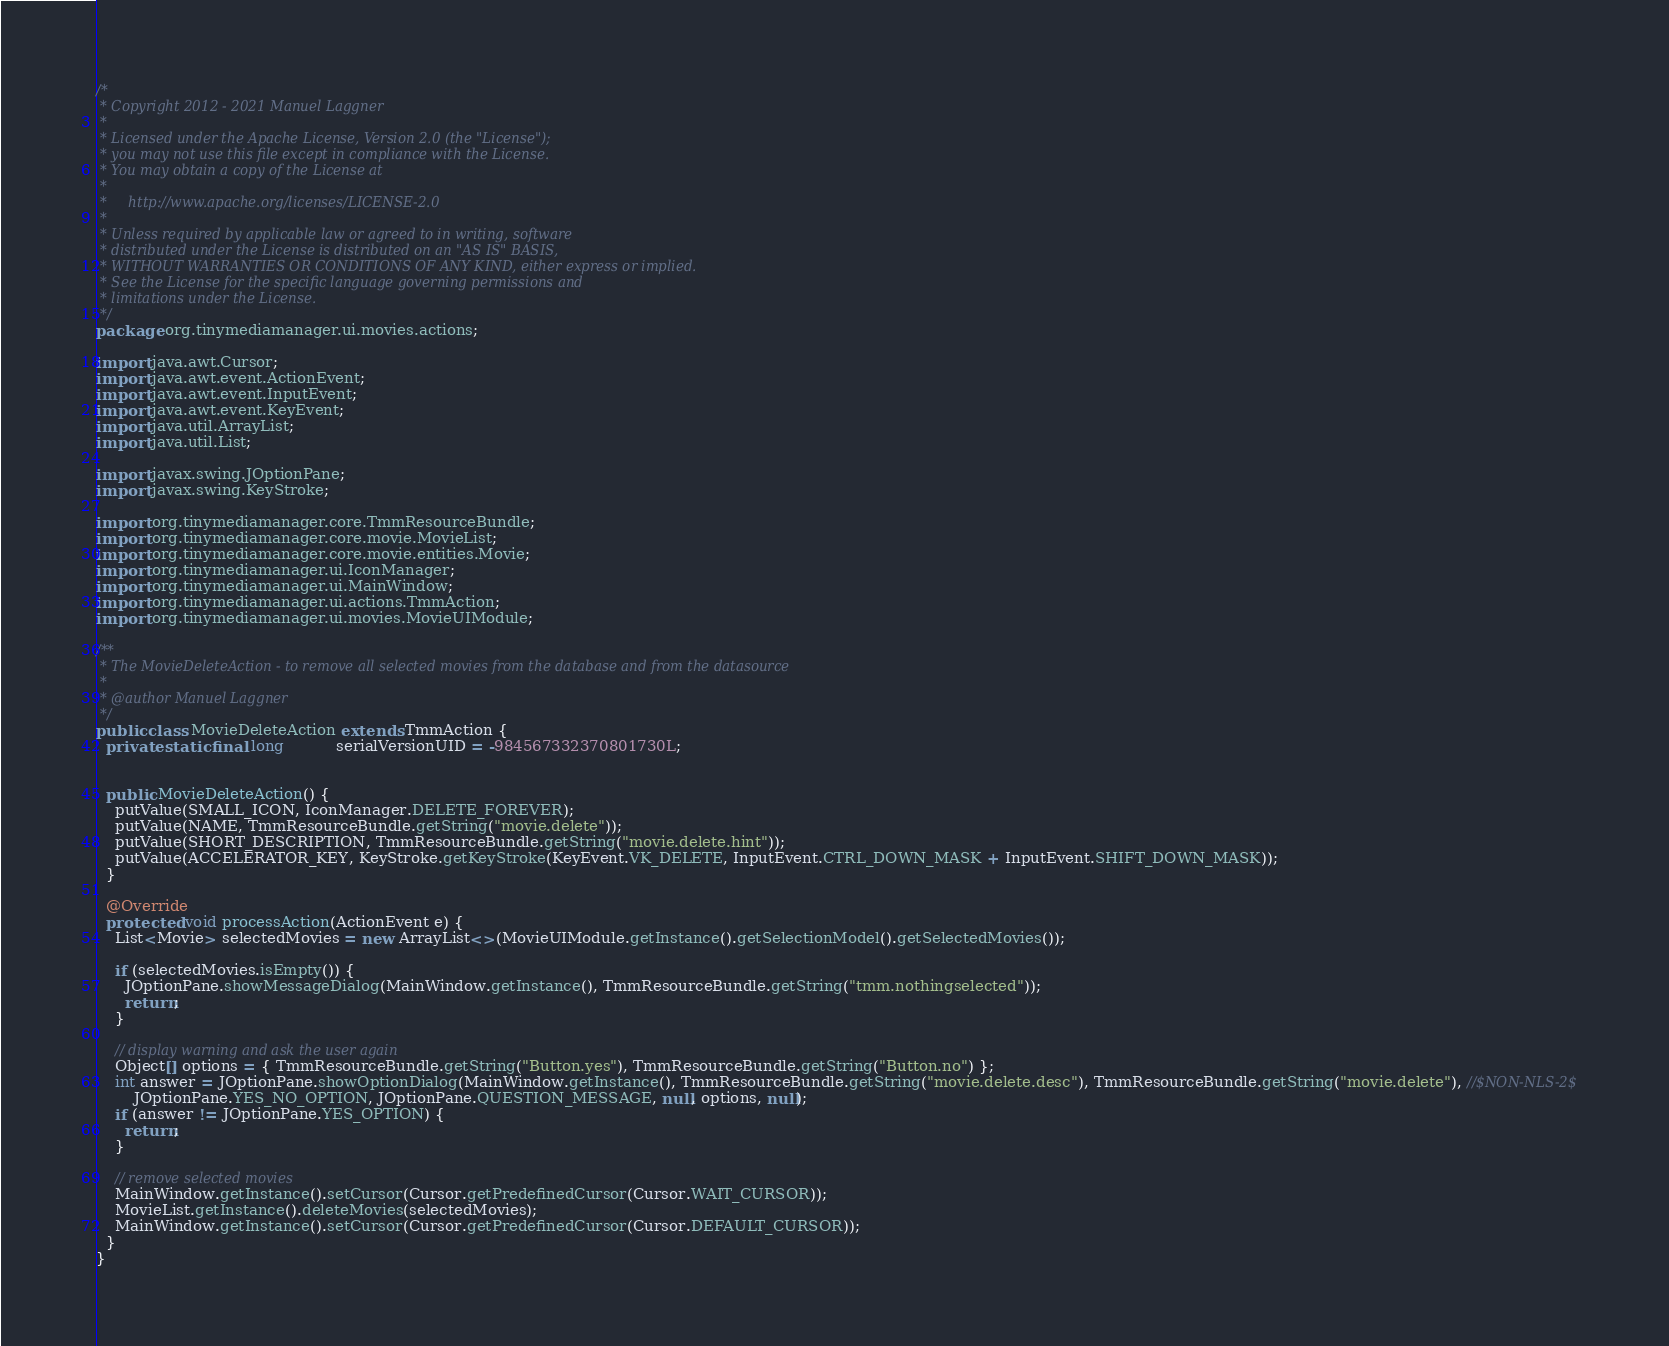Convert code to text. <code><loc_0><loc_0><loc_500><loc_500><_Java_>/*
 * Copyright 2012 - 2021 Manuel Laggner
 *
 * Licensed under the Apache License, Version 2.0 (the "License");
 * you may not use this file except in compliance with the License.
 * You may obtain a copy of the License at
 *
 *     http://www.apache.org/licenses/LICENSE-2.0
 *
 * Unless required by applicable law or agreed to in writing, software
 * distributed under the License is distributed on an "AS IS" BASIS,
 * WITHOUT WARRANTIES OR CONDITIONS OF ANY KIND, either express or implied.
 * See the License for the specific language governing permissions and
 * limitations under the License.
 */
package org.tinymediamanager.ui.movies.actions;

import java.awt.Cursor;
import java.awt.event.ActionEvent;
import java.awt.event.InputEvent;
import java.awt.event.KeyEvent;
import java.util.ArrayList;
import java.util.List;

import javax.swing.JOptionPane;
import javax.swing.KeyStroke;

import org.tinymediamanager.core.TmmResourceBundle;
import org.tinymediamanager.core.movie.MovieList;
import org.tinymediamanager.core.movie.entities.Movie;
import org.tinymediamanager.ui.IconManager;
import org.tinymediamanager.ui.MainWindow;
import org.tinymediamanager.ui.actions.TmmAction;
import org.tinymediamanager.ui.movies.MovieUIModule;

/**
 * The MovieDeleteAction - to remove all selected movies from the database and from the datasource
 * 
 * @author Manuel Laggner
 */
public class MovieDeleteAction extends TmmAction {
  private static final long           serialVersionUID = -984567332370801730L;
  

  public MovieDeleteAction() {
    putValue(SMALL_ICON, IconManager.DELETE_FOREVER);
    putValue(NAME, TmmResourceBundle.getString("movie.delete"));
    putValue(SHORT_DESCRIPTION, TmmResourceBundle.getString("movie.delete.hint"));
    putValue(ACCELERATOR_KEY, KeyStroke.getKeyStroke(KeyEvent.VK_DELETE, InputEvent.CTRL_DOWN_MASK + InputEvent.SHIFT_DOWN_MASK));
  }

  @Override
  protected void processAction(ActionEvent e) {
    List<Movie> selectedMovies = new ArrayList<>(MovieUIModule.getInstance().getSelectionModel().getSelectedMovies());

    if (selectedMovies.isEmpty()) {
      JOptionPane.showMessageDialog(MainWindow.getInstance(), TmmResourceBundle.getString("tmm.nothingselected"));
      return;
    }

    // display warning and ask the user again
    Object[] options = { TmmResourceBundle.getString("Button.yes"), TmmResourceBundle.getString("Button.no") };
    int answer = JOptionPane.showOptionDialog(MainWindow.getInstance(), TmmResourceBundle.getString("movie.delete.desc"), TmmResourceBundle.getString("movie.delete"), //$NON-NLS-2$
        JOptionPane.YES_NO_OPTION, JOptionPane.QUESTION_MESSAGE, null, options, null);
    if (answer != JOptionPane.YES_OPTION) {
      return;
    }

    // remove selected movies
    MainWindow.getInstance().setCursor(Cursor.getPredefinedCursor(Cursor.WAIT_CURSOR));
    MovieList.getInstance().deleteMovies(selectedMovies);
    MainWindow.getInstance().setCursor(Cursor.getPredefinedCursor(Cursor.DEFAULT_CURSOR));
  }
}
</code> 